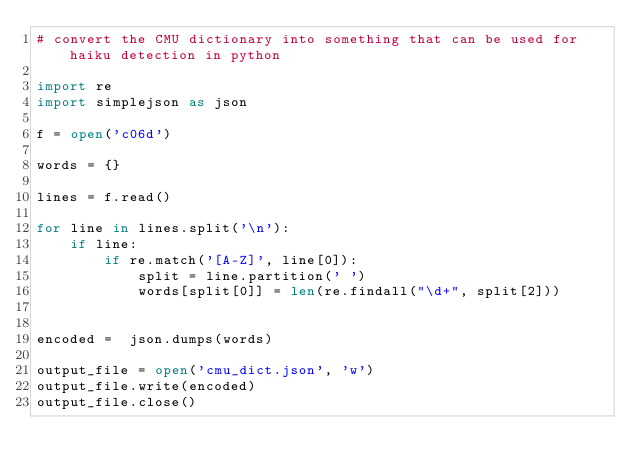<code> <loc_0><loc_0><loc_500><loc_500><_Python_># convert the CMU dictionary into something that can be used for haiku detection in python

import re
import simplejson as json

f = open('c06d')

words = {}

lines = f.read()

for line in lines.split('\n'):
    if line:
        if re.match('[A-Z]', line[0]):
            split = line.partition(' ')
            words[split[0]] = len(re.findall("\d+", split[2]))
        
        
encoded =  json.dumps(words)

output_file = open('cmu_dict.json', 'w')
output_file.write(encoded)
output_file.close()</code> 